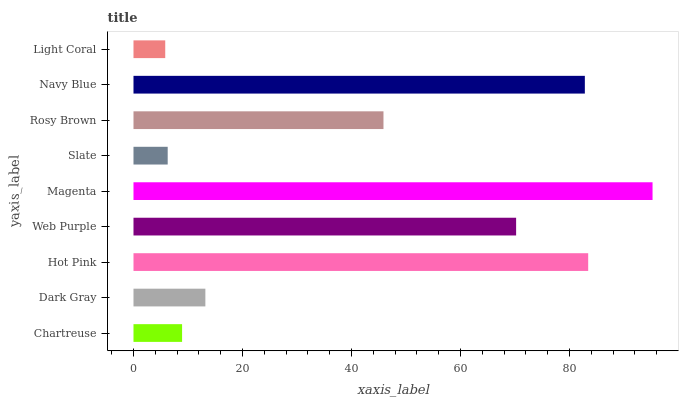Is Light Coral the minimum?
Answer yes or no. Yes. Is Magenta the maximum?
Answer yes or no. Yes. Is Dark Gray the minimum?
Answer yes or no. No. Is Dark Gray the maximum?
Answer yes or no. No. Is Dark Gray greater than Chartreuse?
Answer yes or no. Yes. Is Chartreuse less than Dark Gray?
Answer yes or no. Yes. Is Chartreuse greater than Dark Gray?
Answer yes or no. No. Is Dark Gray less than Chartreuse?
Answer yes or no. No. Is Rosy Brown the high median?
Answer yes or no. Yes. Is Rosy Brown the low median?
Answer yes or no. Yes. Is Web Purple the high median?
Answer yes or no. No. Is Magenta the low median?
Answer yes or no. No. 